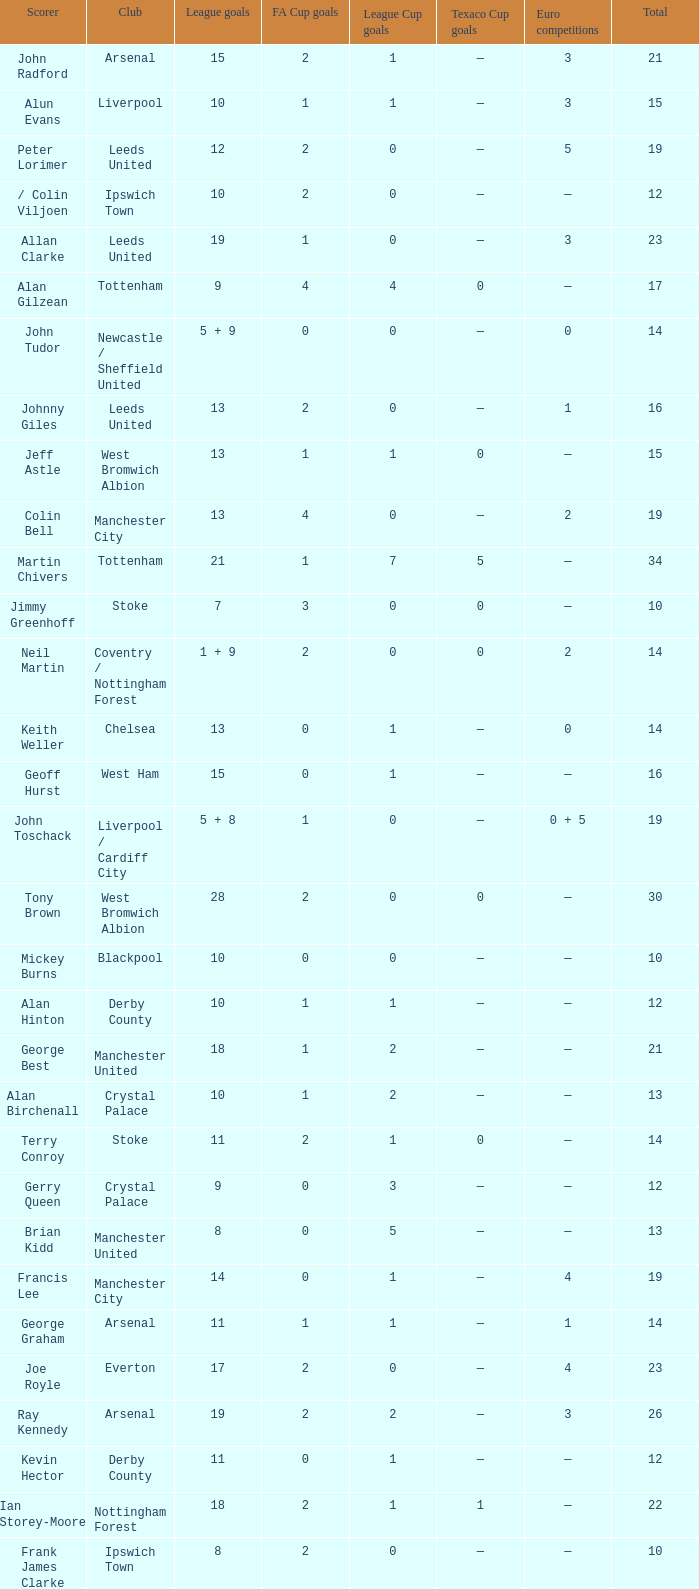What is FA Cup Goals, when Euro Competitions is 1, and when League Goals is 11? 1.0. 